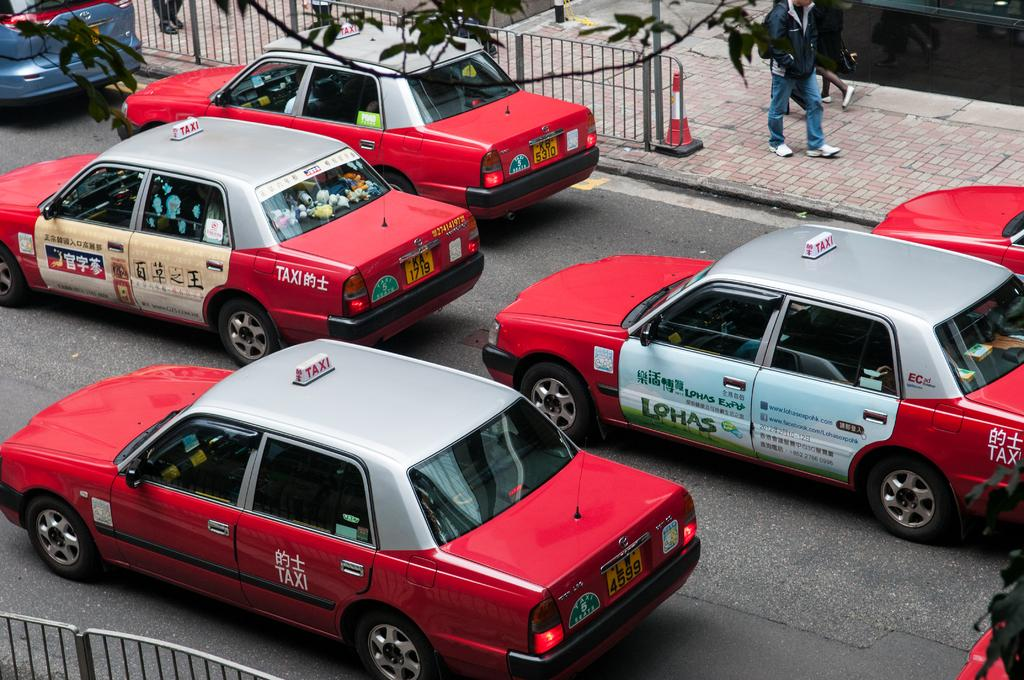<image>
Present a compact description of the photo's key features. Red taxis are lined up on the street, with one that has an advertisement for Lohas Expo on the door in the middle lane. 